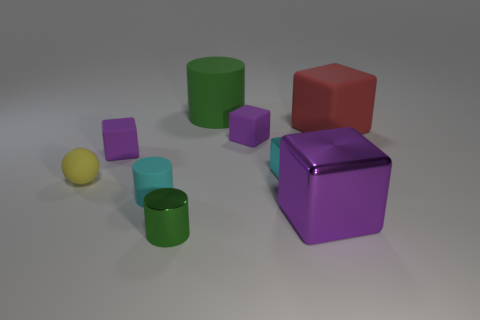Subtract all small rubber cylinders. How many cylinders are left? 2 Add 1 cyan metal spheres. How many objects exist? 10 Subtract all purple cylinders. How many purple cubes are left? 3 Subtract 3 blocks. How many blocks are left? 2 Subtract all cyan blocks. How many blocks are left? 4 Subtract all balls. How many objects are left? 8 Subtract 0 red spheres. How many objects are left? 9 Subtract all gray blocks. Subtract all purple cylinders. How many blocks are left? 5 Subtract all big red shiny spheres. Subtract all tiny yellow rubber things. How many objects are left? 8 Add 7 tiny rubber spheres. How many tiny rubber spheres are left? 8 